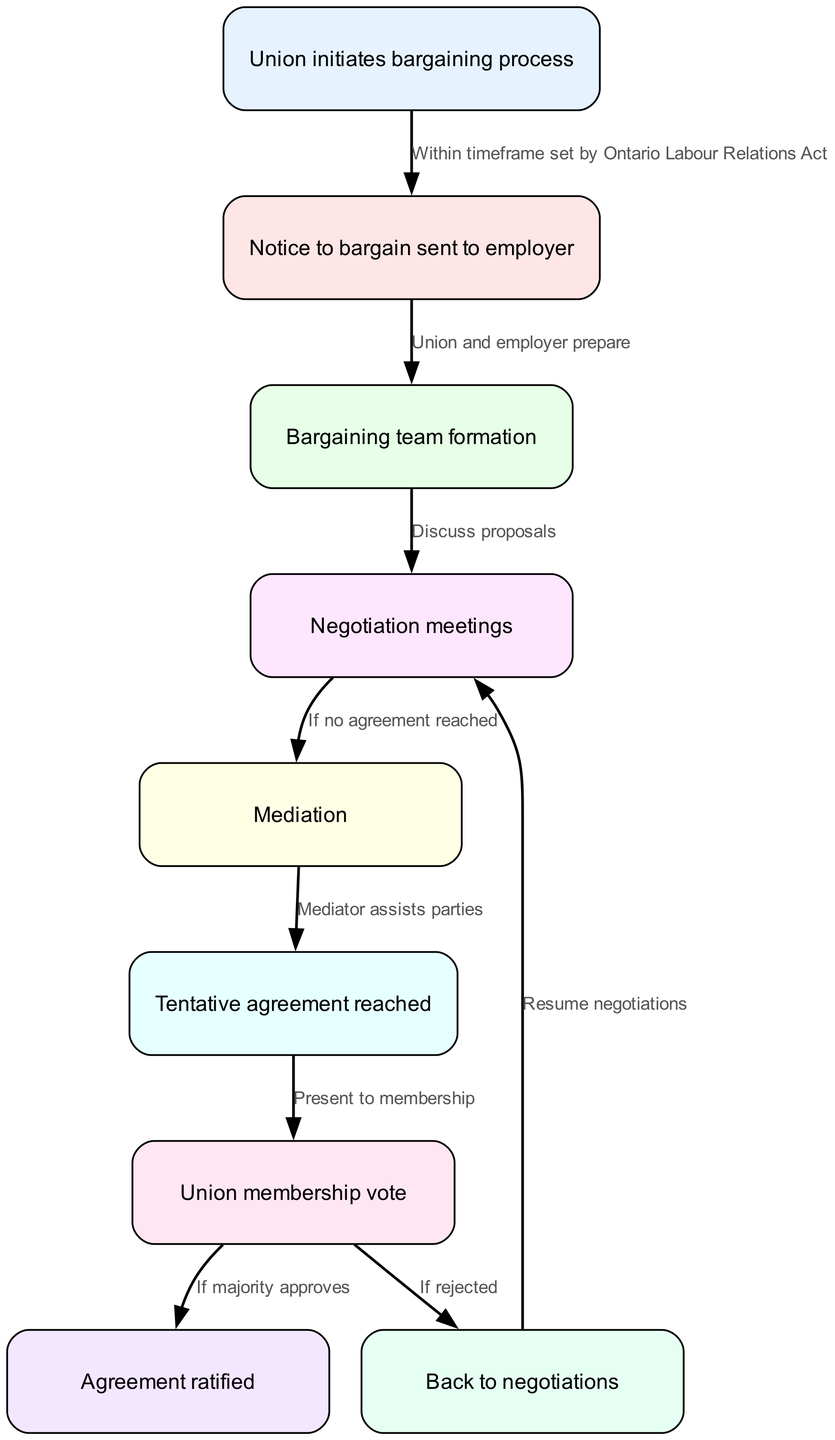What is the first step in the bargaining process? The first step is labeled in the diagram as "Union initiates bargaining process." This is the starting point of the flowchart representing the process of collective bargaining.
Answer: Union initiates bargaining process How many nodes are present in the diagram? By counting the individual steps or components provided in the diagram, there are a total of 9 nodes listed, from the initiation of the bargaining process to the agreement ratification.
Answer: 9 What happens after the "Tentative agreement reached"? Following the "Tentative agreement reached," the next step in the flowchart is "Union membership vote." This indicates that once a tentative agreement is established, it needs to be voted on by the union members.
Answer: Union membership vote What is the outcome if the union membership vote is rejected? If the union membership vote is rejected, the diagram indicates that the process will go "Back to negotiations." This shows that the bargaining process will resume rather than conclude.
Answer: Back to negotiations What is the relationship between "Negotiation meetings" and "Mediation"? The relationship is indicated by an edge in the diagram that states "If no agreement reached." This implies that if the negotiation meetings do not yield an agreement, the next step is to enter mediation.
Answer: If no agreement reached What is the last step in the bargaining process? The last step, as shown in the flowchart, is "Agreement ratified," meaning that after the negotiations and voting processes, the final approval of the agreement occurs here.
Answer: Agreement ratified What assists parties during mediation? The diagram states that "Mediator assists parties," making it clear that mediation involves a mediator's facilitation to help resolve disputes or reach an agreement when necessary.
Answer: Mediator assists parties What does the "Notice to bargain sent to employer" signify? This step indicates a formal notification by the union to the employer, signaling the commencement of the bargaining process as mandated and is an essential legal step within the timeframe set by the Ontario Labour Relations Act.
Answer: Notice to bargain sent to employer 